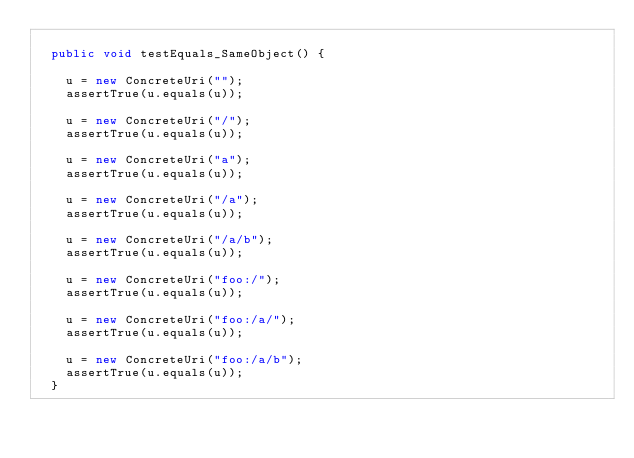Convert code to text. <code><loc_0><loc_0><loc_500><loc_500><_Java_>	
	public void testEquals_SameObject() {
		
		u = new ConcreteUri("");
		assertTrue(u.equals(u));

		u = new ConcreteUri("/");
		assertTrue(u.equals(u));

		u = new ConcreteUri("a");
		assertTrue(u.equals(u));

		u = new ConcreteUri("/a");
		assertTrue(u.equals(u));

		u = new ConcreteUri("/a/b");
		assertTrue(u.equals(u));

		u = new ConcreteUri("foo:/");
		assertTrue(u.equals(u));

		u = new ConcreteUri("foo:/a/");
		assertTrue(u.equals(u));

		u = new ConcreteUri("foo:/a/b");
		assertTrue(u.equals(u));
	}
	</code> 